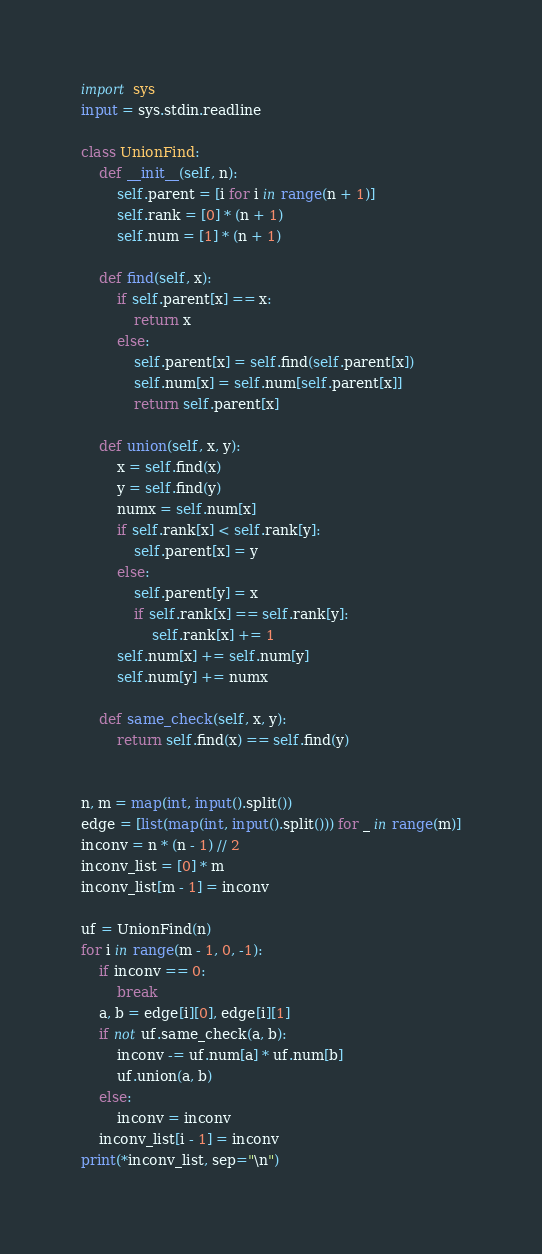Convert code to text. <code><loc_0><loc_0><loc_500><loc_500><_Python_>import sys
input = sys.stdin.readline

class UnionFind:
    def __init__(self, n):
        self.parent = [i for i in range(n + 1)]
        self.rank = [0] * (n + 1)
        self.num = [1] * (n + 1)

    def find(self, x):
        if self.parent[x] == x:
            return x
        else:
            self.parent[x] = self.find(self.parent[x])
            self.num[x] = self.num[self.parent[x]]
            return self.parent[x]

    def union(self, x, y):
        x = self.find(x)
        y = self.find(y)
        numx = self.num[x]
        if self.rank[x] < self.rank[y]:
            self.parent[x] = y
        else:
            self.parent[y] = x
            if self.rank[x] == self.rank[y]:
                self.rank[x] += 1
        self.num[x] += self.num[y]
        self.num[y] += numx

    def same_check(self, x, y):
        return self.find(x) == self.find(y)


n, m = map(int, input().split())
edge = [list(map(int, input().split())) for _ in range(m)]
inconv = n * (n - 1) // 2
inconv_list = [0] * m
inconv_list[m - 1] = inconv

uf = UnionFind(n)
for i in range(m - 1, 0, -1):
    if inconv == 0:
        break
    a, b = edge[i][0], edge[i][1]
    if not uf.same_check(a, b):
        inconv -= uf.num[a] * uf.num[b]
        uf.union(a, b)
    else:
        inconv = inconv
    inconv_list[i - 1] = inconv
print(*inconv_list, sep="\n")</code> 